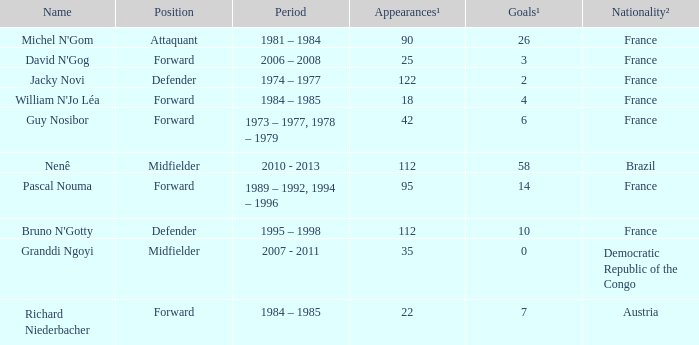List the number of active years for attaquant. 1981 – 1984. 